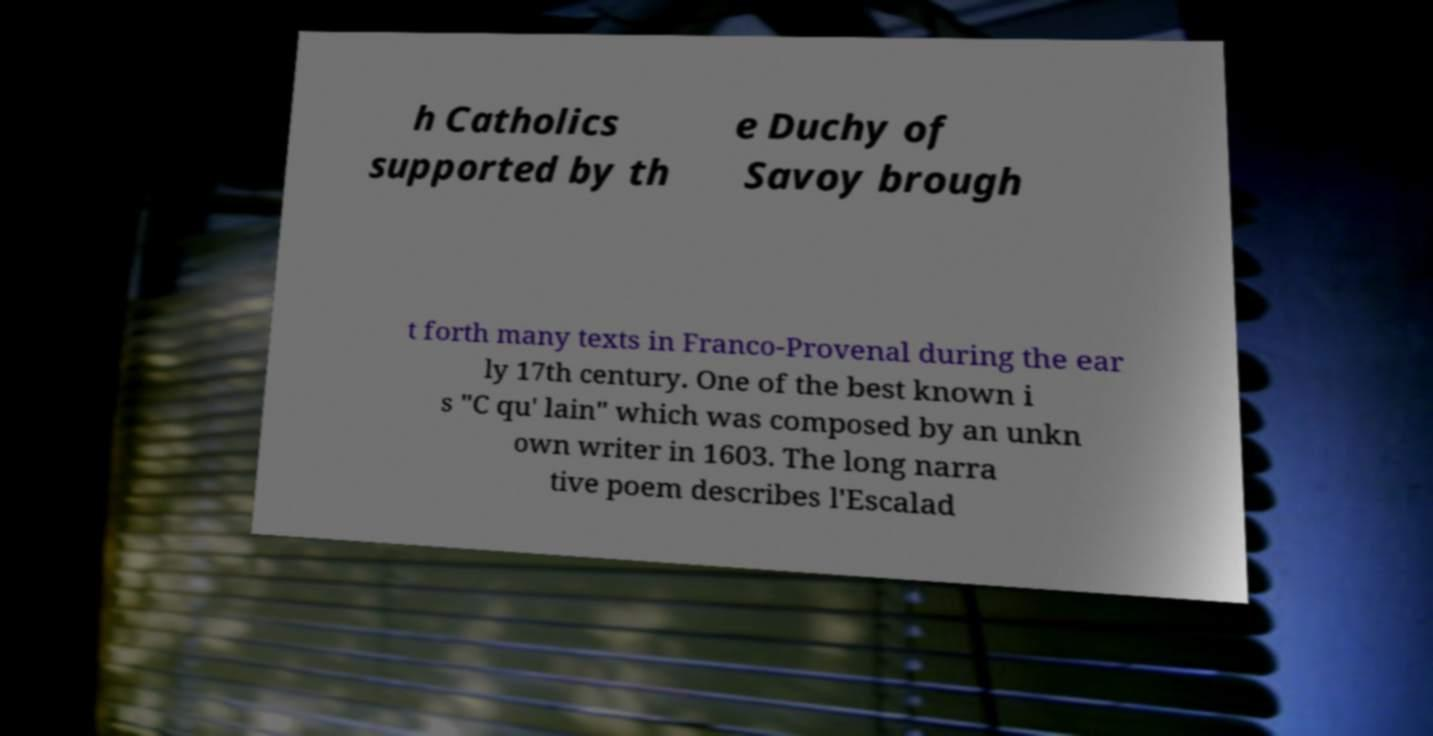Please read and relay the text visible in this image. What does it say? h Catholics supported by th e Duchy of Savoy brough t forth many texts in Franco-Provenal during the ear ly 17th century. One of the best known i s "C qu' lain" which was composed by an unkn own writer in 1603. The long narra tive poem describes l'Escalad 